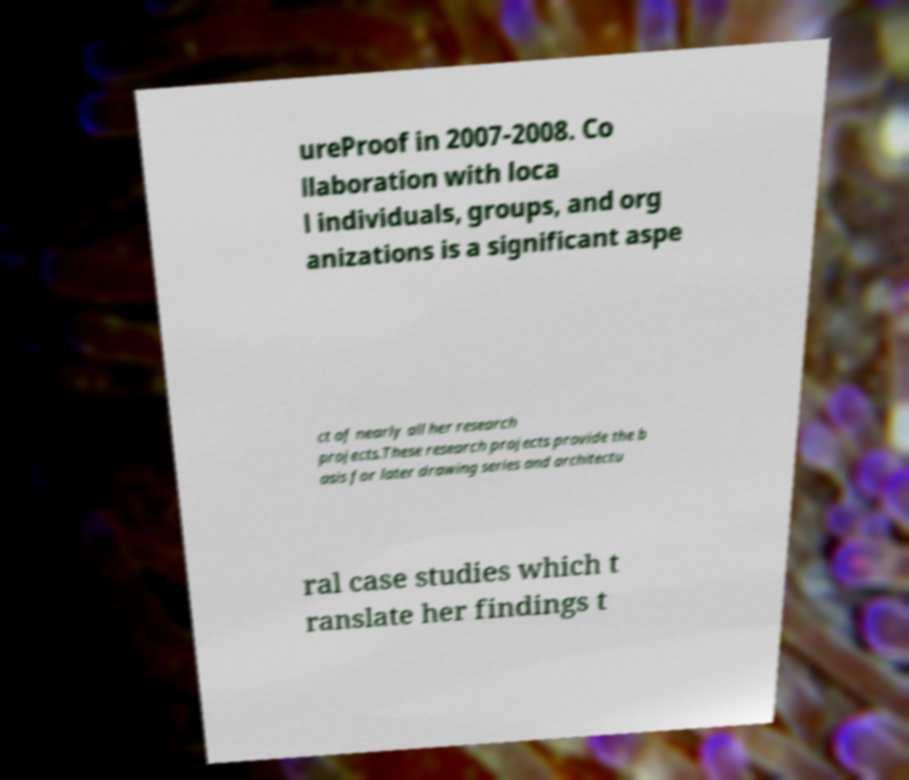Can you read and provide the text displayed in the image?This photo seems to have some interesting text. Can you extract and type it out for me? ureProof in 2007-2008. Co llaboration with loca l individuals, groups, and org anizations is a significant aspe ct of nearly all her research projects.These research projects provide the b asis for later drawing series and architectu ral case studies which t ranslate her findings t 